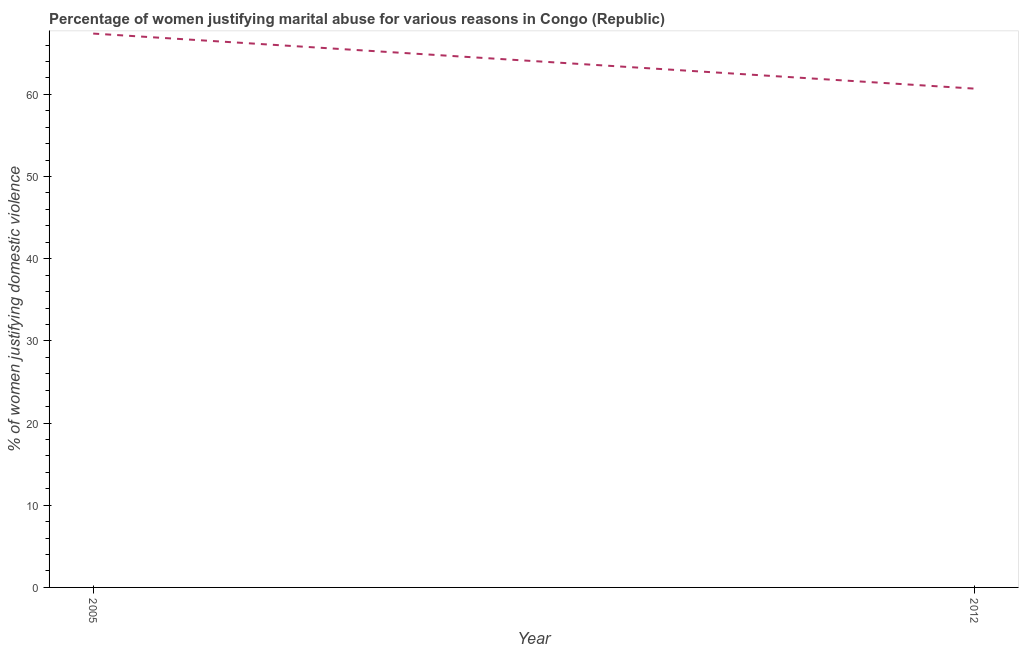What is the percentage of women justifying marital abuse in 2005?
Your response must be concise. 67.4. Across all years, what is the maximum percentage of women justifying marital abuse?
Provide a succinct answer. 67.4. Across all years, what is the minimum percentage of women justifying marital abuse?
Give a very brief answer. 60.7. What is the sum of the percentage of women justifying marital abuse?
Keep it short and to the point. 128.1. What is the difference between the percentage of women justifying marital abuse in 2005 and 2012?
Keep it short and to the point. 6.7. What is the average percentage of women justifying marital abuse per year?
Ensure brevity in your answer.  64.05. What is the median percentage of women justifying marital abuse?
Keep it short and to the point. 64.05. What is the ratio of the percentage of women justifying marital abuse in 2005 to that in 2012?
Provide a succinct answer. 1.11. Is the percentage of women justifying marital abuse in 2005 less than that in 2012?
Your response must be concise. No. How many years are there in the graph?
Your response must be concise. 2. Are the values on the major ticks of Y-axis written in scientific E-notation?
Provide a short and direct response. No. What is the title of the graph?
Your answer should be very brief. Percentage of women justifying marital abuse for various reasons in Congo (Republic). What is the label or title of the Y-axis?
Your answer should be compact. % of women justifying domestic violence. What is the % of women justifying domestic violence of 2005?
Your response must be concise. 67.4. What is the % of women justifying domestic violence of 2012?
Keep it short and to the point. 60.7. What is the difference between the % of women justifying domestic violence in 2005 and 2012?
Provide a short and direct response. 6.7. What is the ratio of the % of women justifying domestic violence in 2005 to that in 2012?
Offer a terse response. 1.11. 